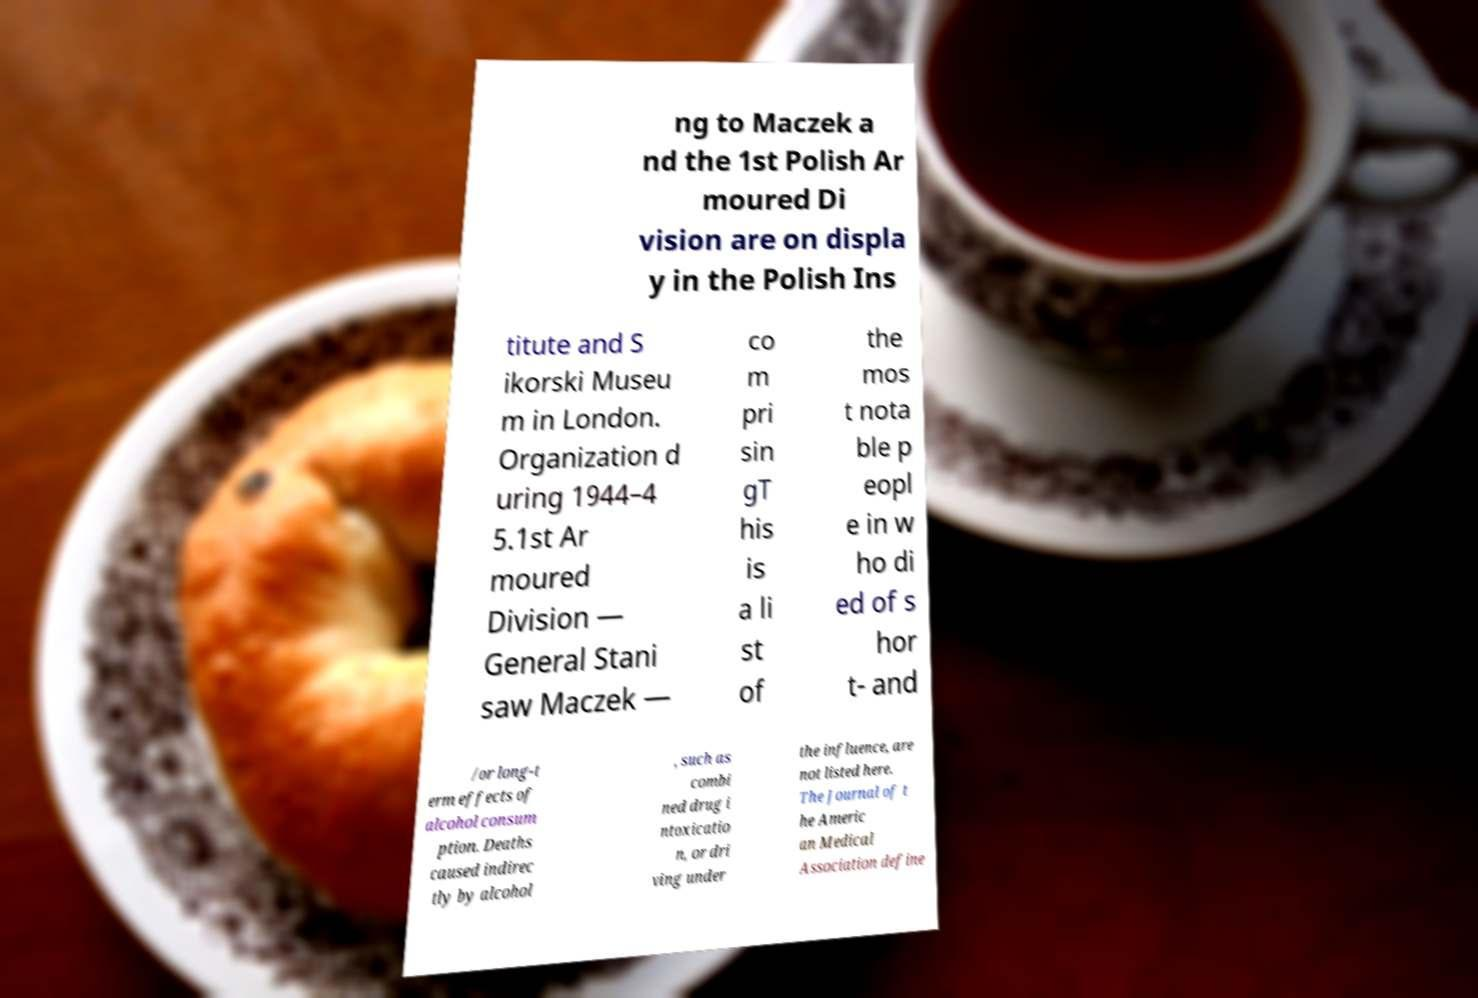There's text embedded in this image that I need extracted. Can you transcribe it verbatim? ng to Maczek a nd the 1st Polish Ar moured Di vision are on displa y in the Polish Ins titute and S ikorski Museu m in London. Organization d uring 1944–4 5.1st Ar moured Division — General Stani saw Maczek — co m pri sin gT his is a li st of the mos t nota ble p eopl e in w ho di ed of s hor t- and /or long-t erm effects of alcohol consum ption. Deaths caused indirec tly by alcohol , such as combi ned drug i ntoxicatio n, or dri ving under the influence, are not listed here. The Journal of t he Americ an Medical Association define 